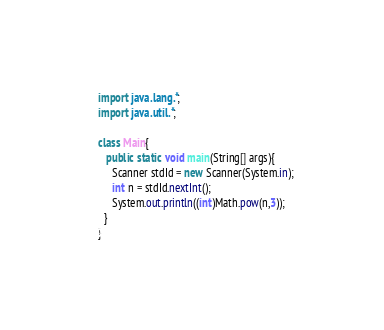<code> <loc_0><loc_0><loc_500><loc_500><_Java_>import java.lang.*;
import java.util.*;
  
class Main{
   public static void main(String[] args){
     Scanner stdId = new Scanner(System.in);
     int n = stdId.nextInt(); 
     System.out.println((int)Math.pow(n,3));
  }
}</code> 